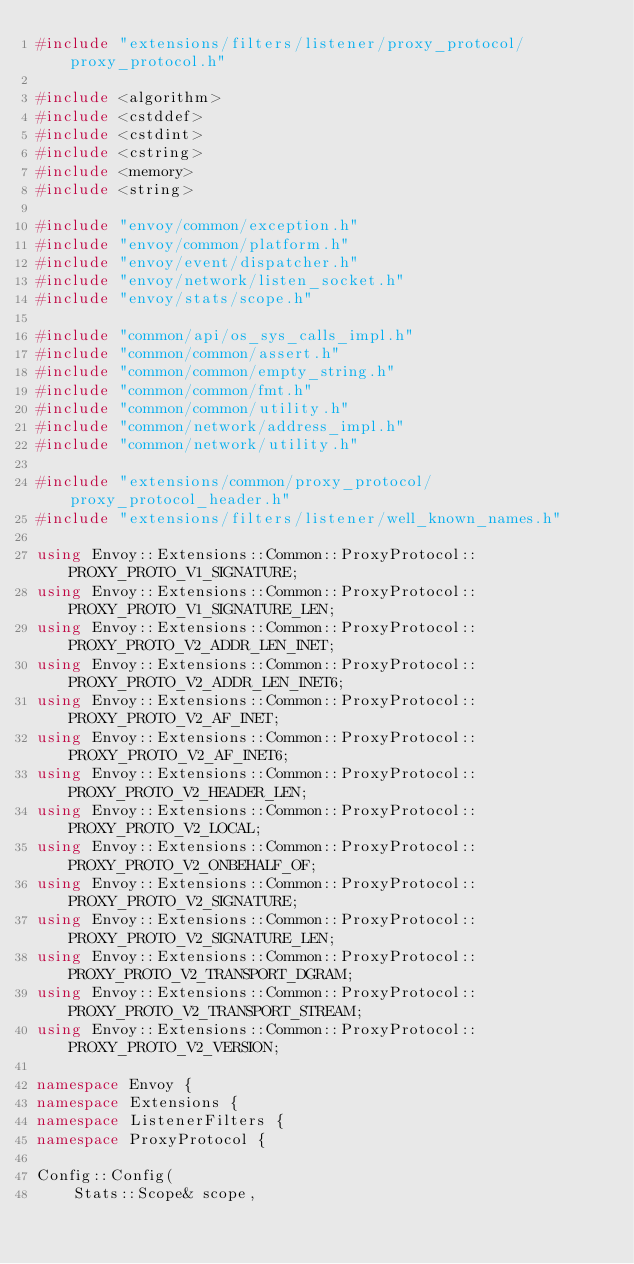<code> <loc_0><loc_0><loc_500><loc_500><_C++_>#include "extensions/filters/listener/proxy_protocol/proxy_protocol.h"

#include <algorithm>
#include <cstddef>
#include <cstdint>
#include <cstring>
#include <memory>
#include <string>

#include "envoy/common/exception.h"
#include "envoy/common/platform.h"
#include "envoy/event/dispatcher.h"
#include "envoy/network/listen_socket.h"
#include "envoy/stats/scope.h"

#include "common/api/os_sys_calls_impl.h"
#include "common/common/assert.h"
#include "common/common/empty_string.h"
#include "common/common/fmt.h"
#include "common/common/utility.h"
#include "common/network/address_impl.h"
#include "common/network/utility.h"

#include "extensions/common/proxy_protocol/proxy_protocol_header.h"
#include "extensions/filters/listener/well_known_names.h"

using Envoy::Extensions::Common::ProxyProtocol::PROXY_PROTO_V1_SIGNATURE;
using Envoy::Extensions::Common::ProxyProtocol::PROXY_PROTO_V1_SIGNATURE_LEN;
using Envoy::Extensions::Common::ProxyProtocol::PROXY_PROTO_V2_ADDR_LEN_INET;
using Envoy::Extensions::Common::ProxyProtocol::PROXY_PROTO_V2_ADDR_LEN_INET6;
using Envoy::Extensions::Common::ProxyProtocol::PROXY_PROTO_V2_AF_INET;
using Envoy::Extensions::Common::ProxyProtocol::PROXY_PROTO_V2_AF_INET6;
using Envoy::Extensions::Common::ProxyProtocol::PROXY_PROTO_V2_HEADER_LEN;
using Envoy::Extensions::Common::ProxyProtocol::PROXY_PROTO_V2_LOCAL;
using Envoy::Extensions::Common::ProxyProtocol::PROXY_PROTO_V2_ONBEHALF_OF;
using Envoy::Extensions::Common::ProxyProtocol::PROXY_PROTO_V2_SIGNATURE;
using Envoy::Extensions::Common::ProxyProtocol::PROXY_PROTO_V2_SIGNATURE_LEN;
using Envoy::Extensions::Common::ProxyProtocol::PROXY_PROTO_V2_TRANSPORT_DGRAM;
using Envoy::Extensions::Common::ProxyProtocol::PROXY_PROTO_V2_TRANSPORT_STREAM;
using Envoy::Extensions::Common::ProxyProtocol::PROXY_PROTO_V2_VERSION;

namespace Envoy {
namespace Extensions {
namespace ListenerFilters {
namespace ProxyProtocol {

Config::Config(
    Stats::Scope& scope,</code> 